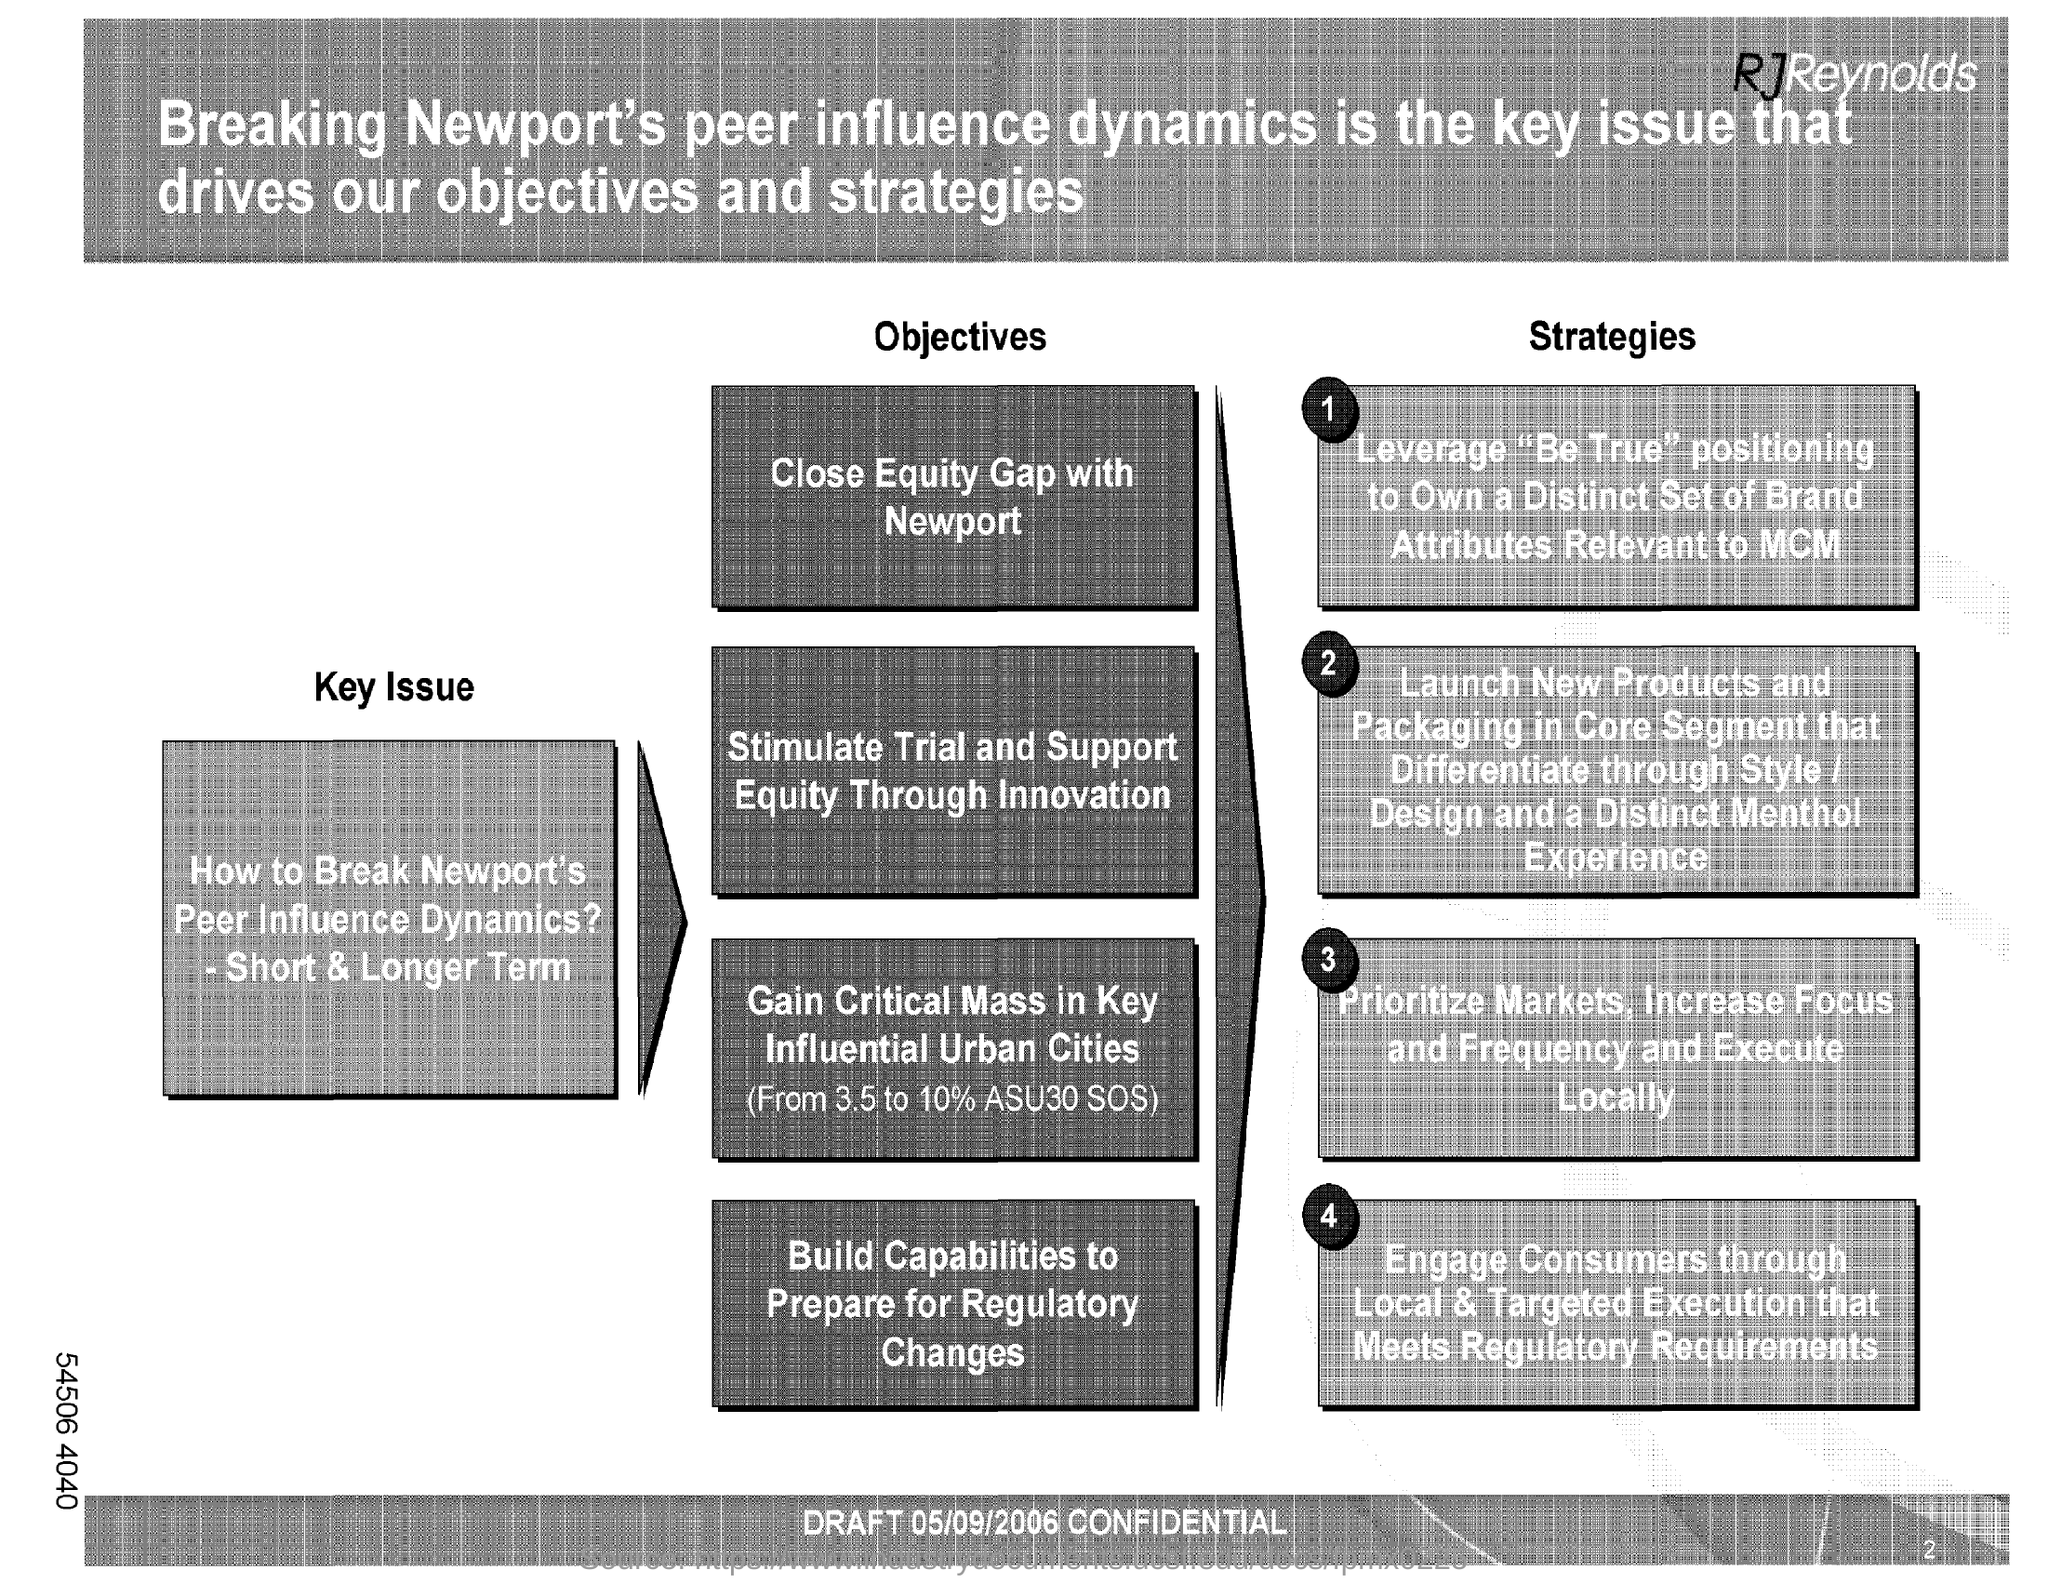Mention a couple of crucial points in this snapshot. The key issue is how to break Newport's peer influence dynamics, both in the short and longer term. 